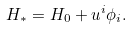Convert formula to latex. <formula><loc_0><loc_0><loc_500><loc_500>H _ { * } = H _ { 0 } + u ^ { i } \phi _ { i } .</formula> 